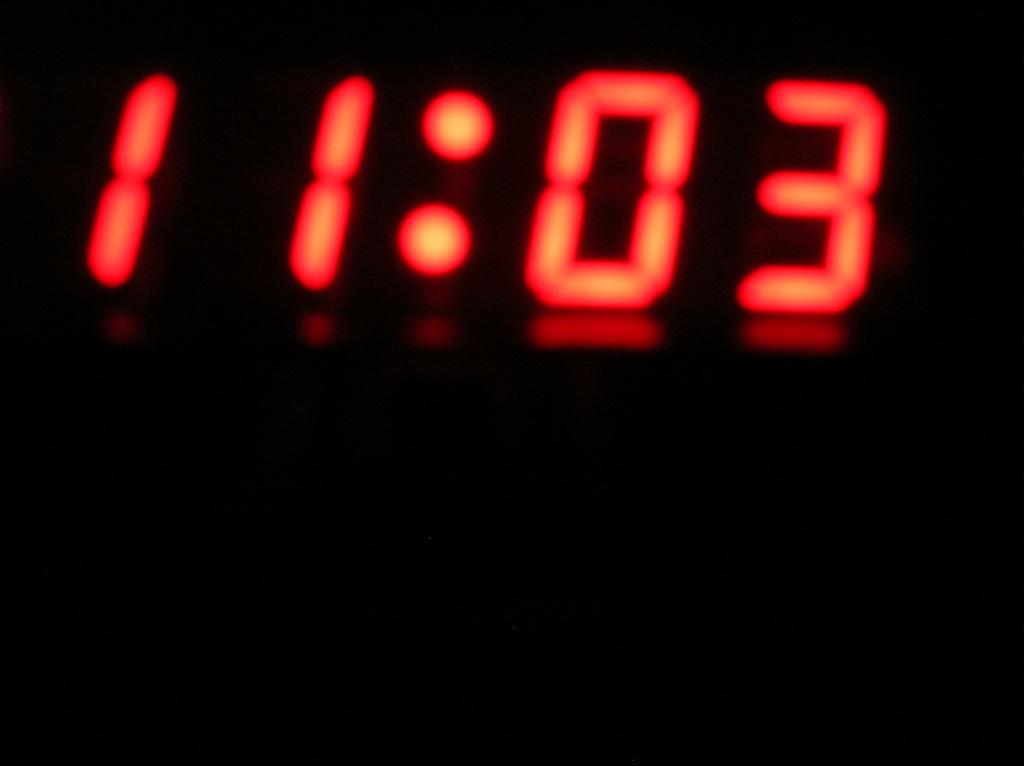What time is it?
Your answer should be compact. 11:03. 